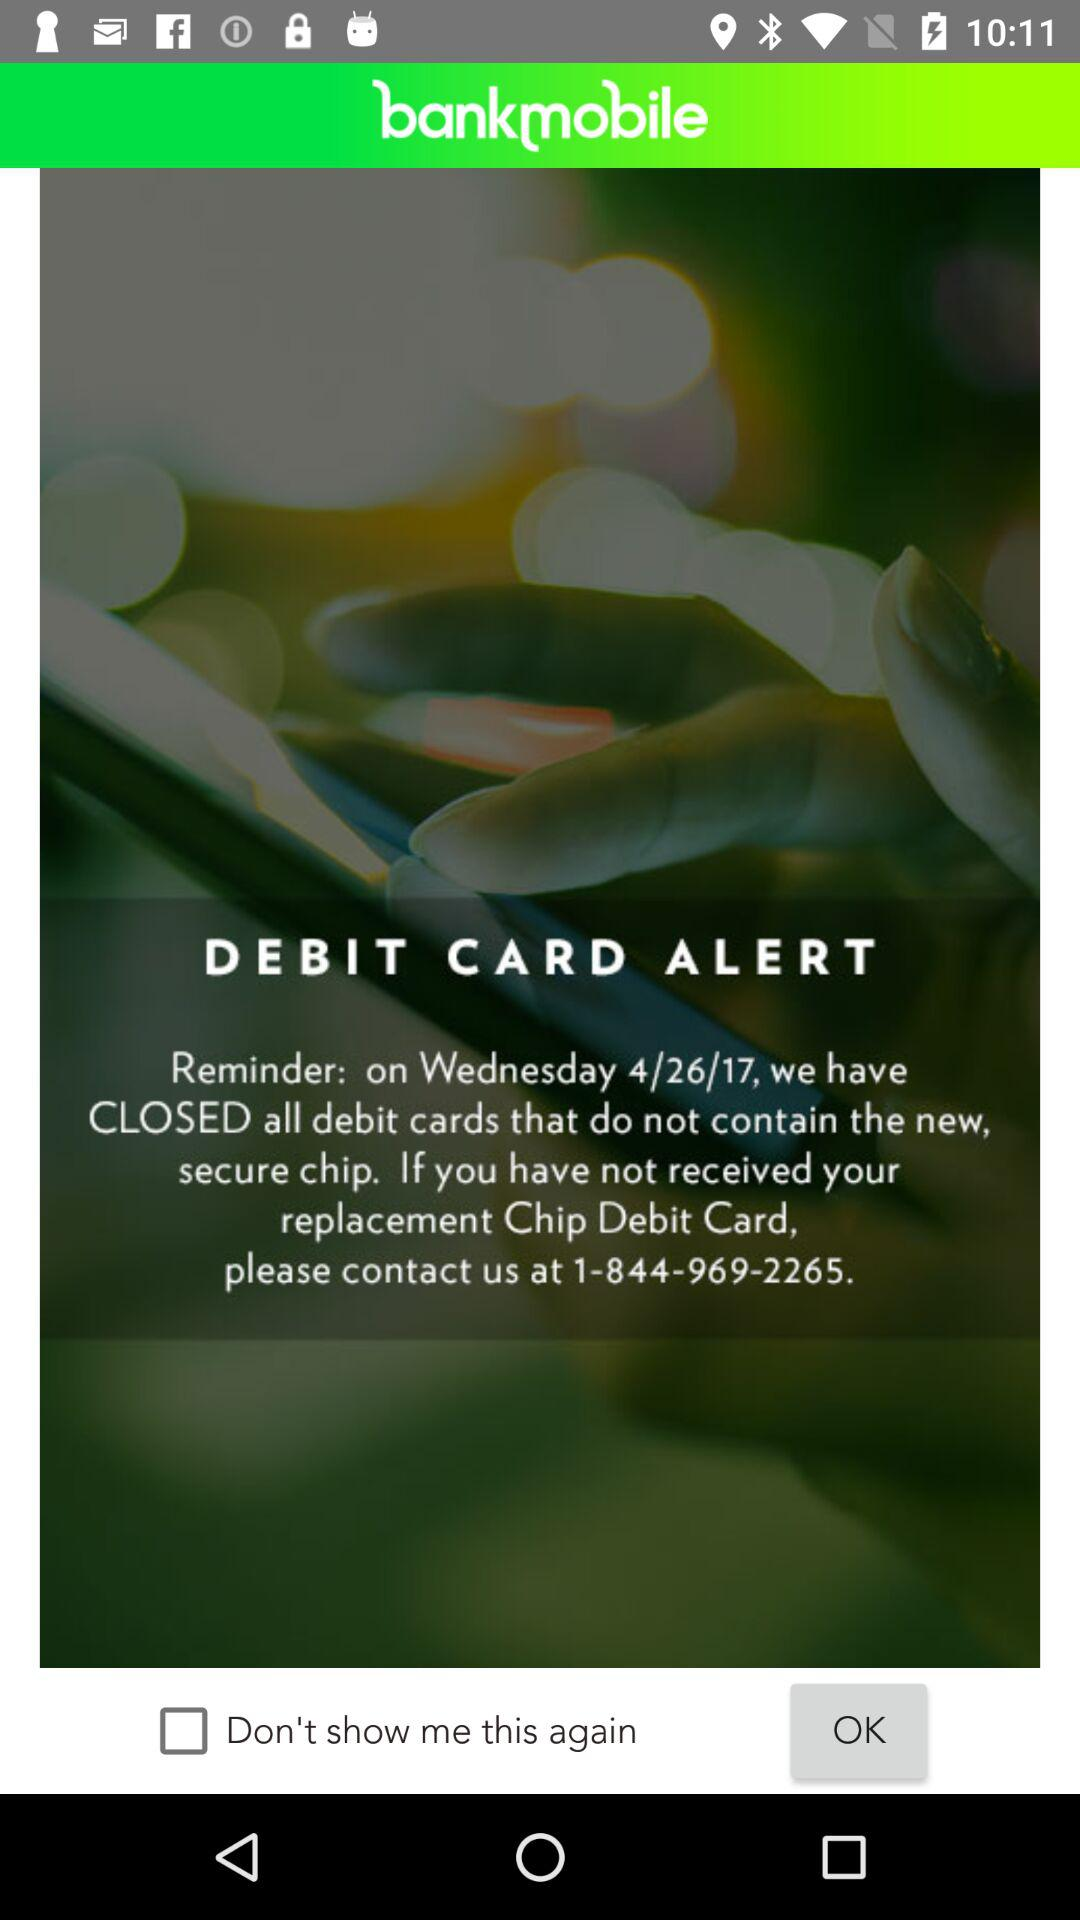What is the status of "Don't show me this again"? The status of "Don't show me this again" is off. 